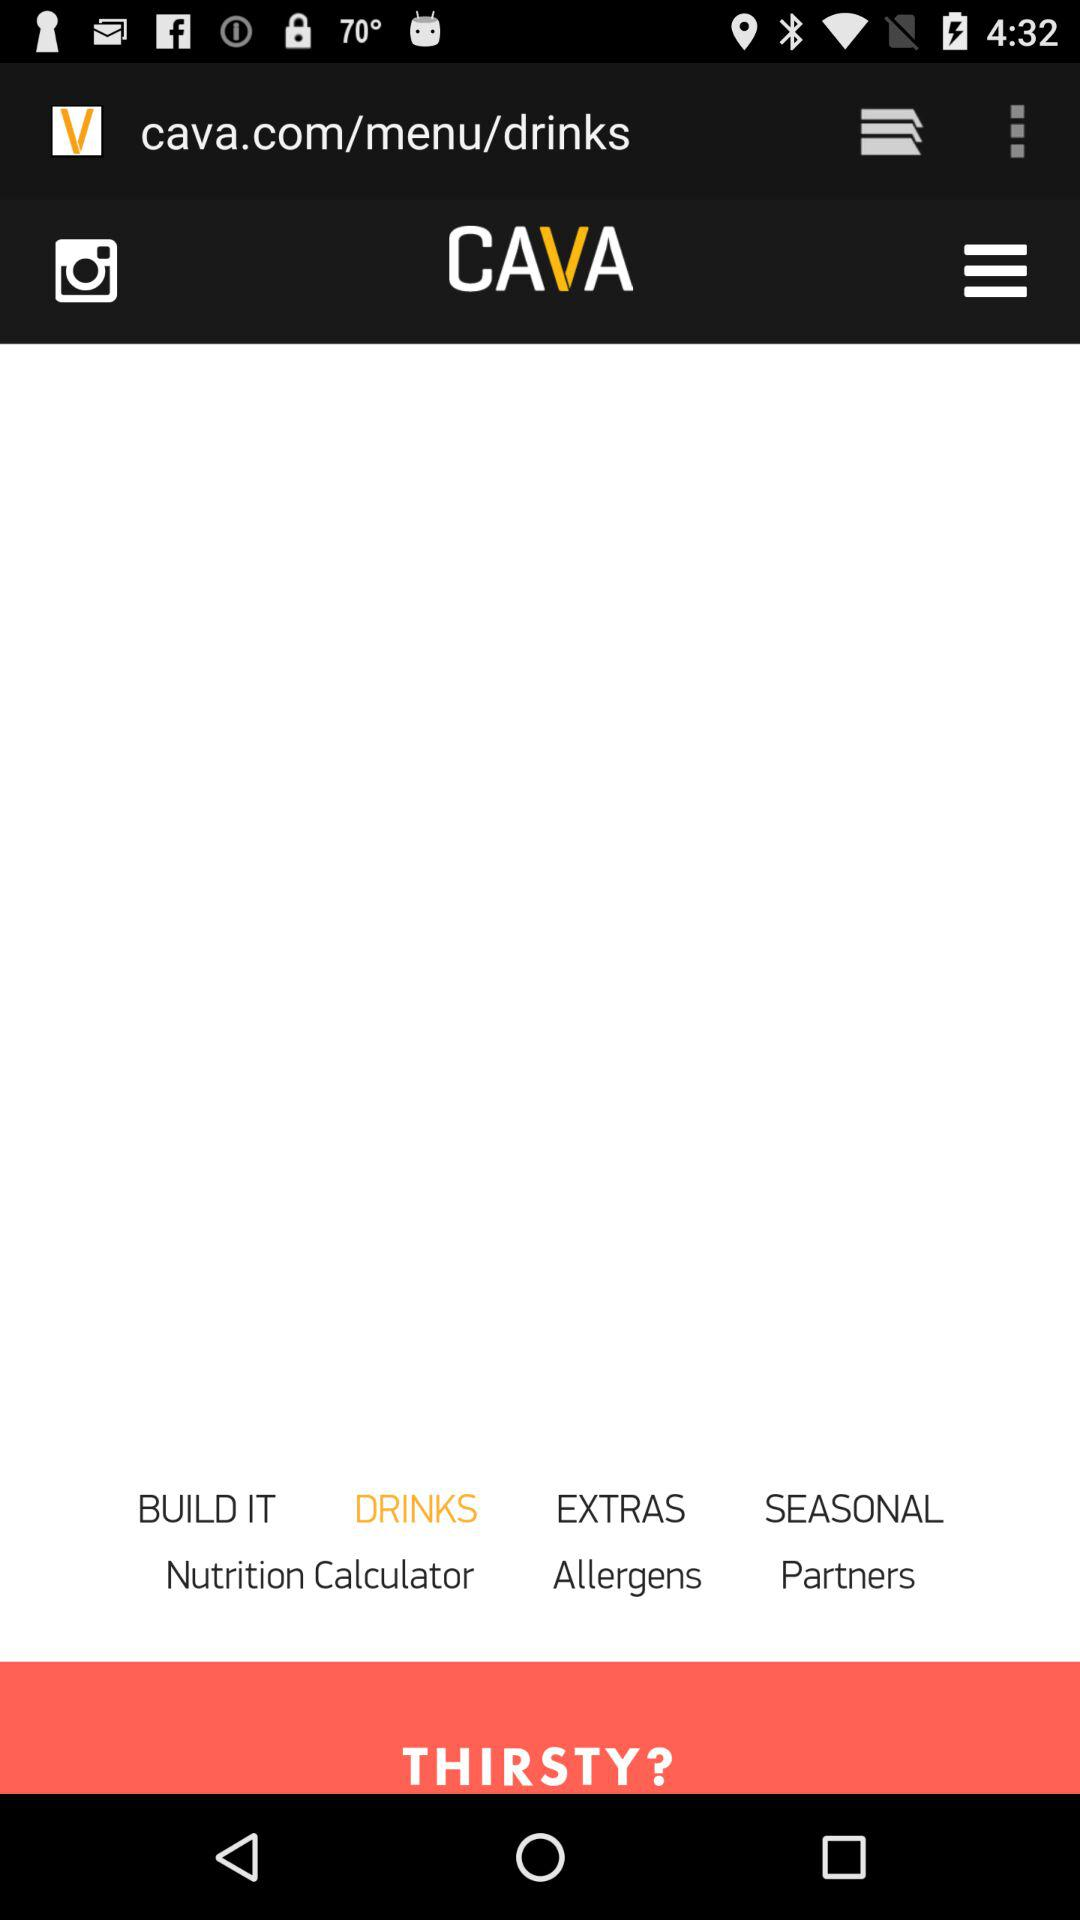What are the listed drinks?
When the provided information is insufficient, respond with <no answer>. <no answer> 